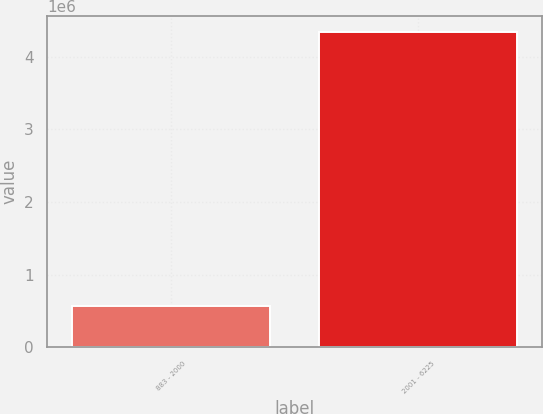<chart> <loc_0><loc_0><loc_500><loc_500><bar_chart><fcel>883 - 2000<fcel>2001 - 6225<nl><fcel>570080<fcel>4.33519e+06<nl></chart> 